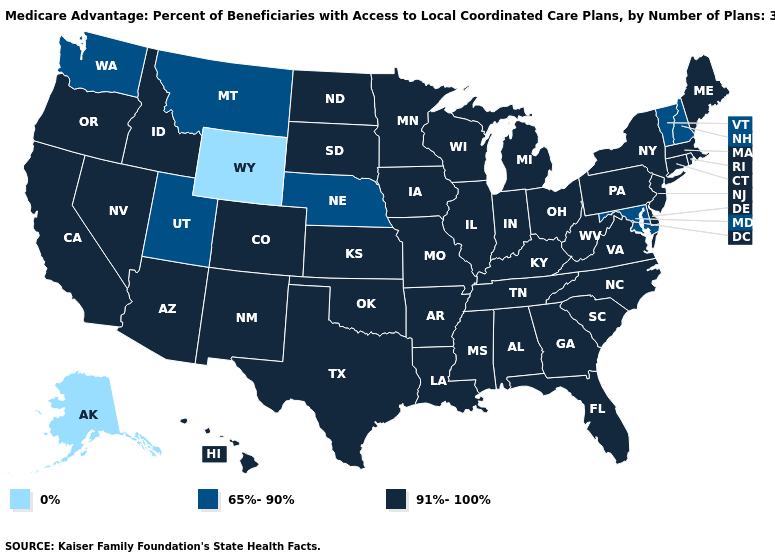Name the states that have a value in the range 65%-90%?
Be succinct. Maryland, Montana, Nebraska, New Hampshire, Utah, Vermont, Washington. Name the states that have a value in the range 91%-100%?
Keep it brief. California, Colorado, Connecticut, Delaware, Florida, Georgia, Hawaii, Iowa, Idaho, Illinois, Indiana, Kansas, Kentucky, Louisiana, Massachusetts, Maine, Michigan, Minnesota, Missouri, Mississippi, North Carolina, North Dakota, New Jersey, New Mexico, Nevada, New York, Ohio, Oklahoma, Oregon, Pennsylvania, Rhode Island, South Carolina, South Dakota, Tennessee, Texas, Virginia, Wisconsin, West Virginia, Alabama, Arkansas, Arizona. Name the states that have a value in the range 91%-100%?
Concise answer only. California, Colorado, Connecticut, Delaware, Florida, Georgia, Hawaii, Iowa, Idaho, Illinois, Indiana, Kansas, Kentucky, Louisiana, Massachusetts, Maine, Michigan, Minnesota, Missouri, Mississippi, North Carolina, North Dakota, New Jersey, New Mexico, Nevada, New York, Ohio, Oklahoma, Oregon, Pennsylvania, Rhode Island, South Carolina, South Dakota, Tennessee, Texas, Virginia, Wisconsin, West Virginia, Alabama, Arkansas, Arizona. How many symbols are there in the legend?
Short answer required. 3. What is the lowest value in the Northeast?
Quick response, please. 65%-90%. What is the lowest value in the USA?
Write a very short answer. 0%. Does Washington have the highest value in the West?
Short answer required. No. Does the first symbol in the legend represent the smallest category?
Answer briefly. Yes. What is the value of Hawaii?
Give a very brief answer. 91%-100%. Does Missouri have the same value as Alaska?
Write a very short answer. No. Does the first symbol in the legend represent the smallest category?
Quick response, please. Yes. Among the states that border Virginia , does Maryland have the highest value?
Keep it brief. No. What is the value of Washington?
Keep it brief. 65%-90%. Name the states that have a value in the range 91%-100%?
Write a very short answer. California, Colorado, Connecticut, Delaware, Florida, Georgia, Hawaii, Iowa, Idaho, Illinois, Indiana, Kansas, Kentucky, Louisiana, Massachusetts, Maine, Michigan, Minnesota, Missouri, Mississippi, North Carolina, North Dakota, New Jersey, New Mexico, Nevada, New York, Ohio, Oklahoma, Oregon, Pennsylvania, Rhode Island, South Carolina, South Dakota, Tennessee, Texas, Virginia, Wisconsin, West Virginia, Alabama, Arkansas, Arizona. 